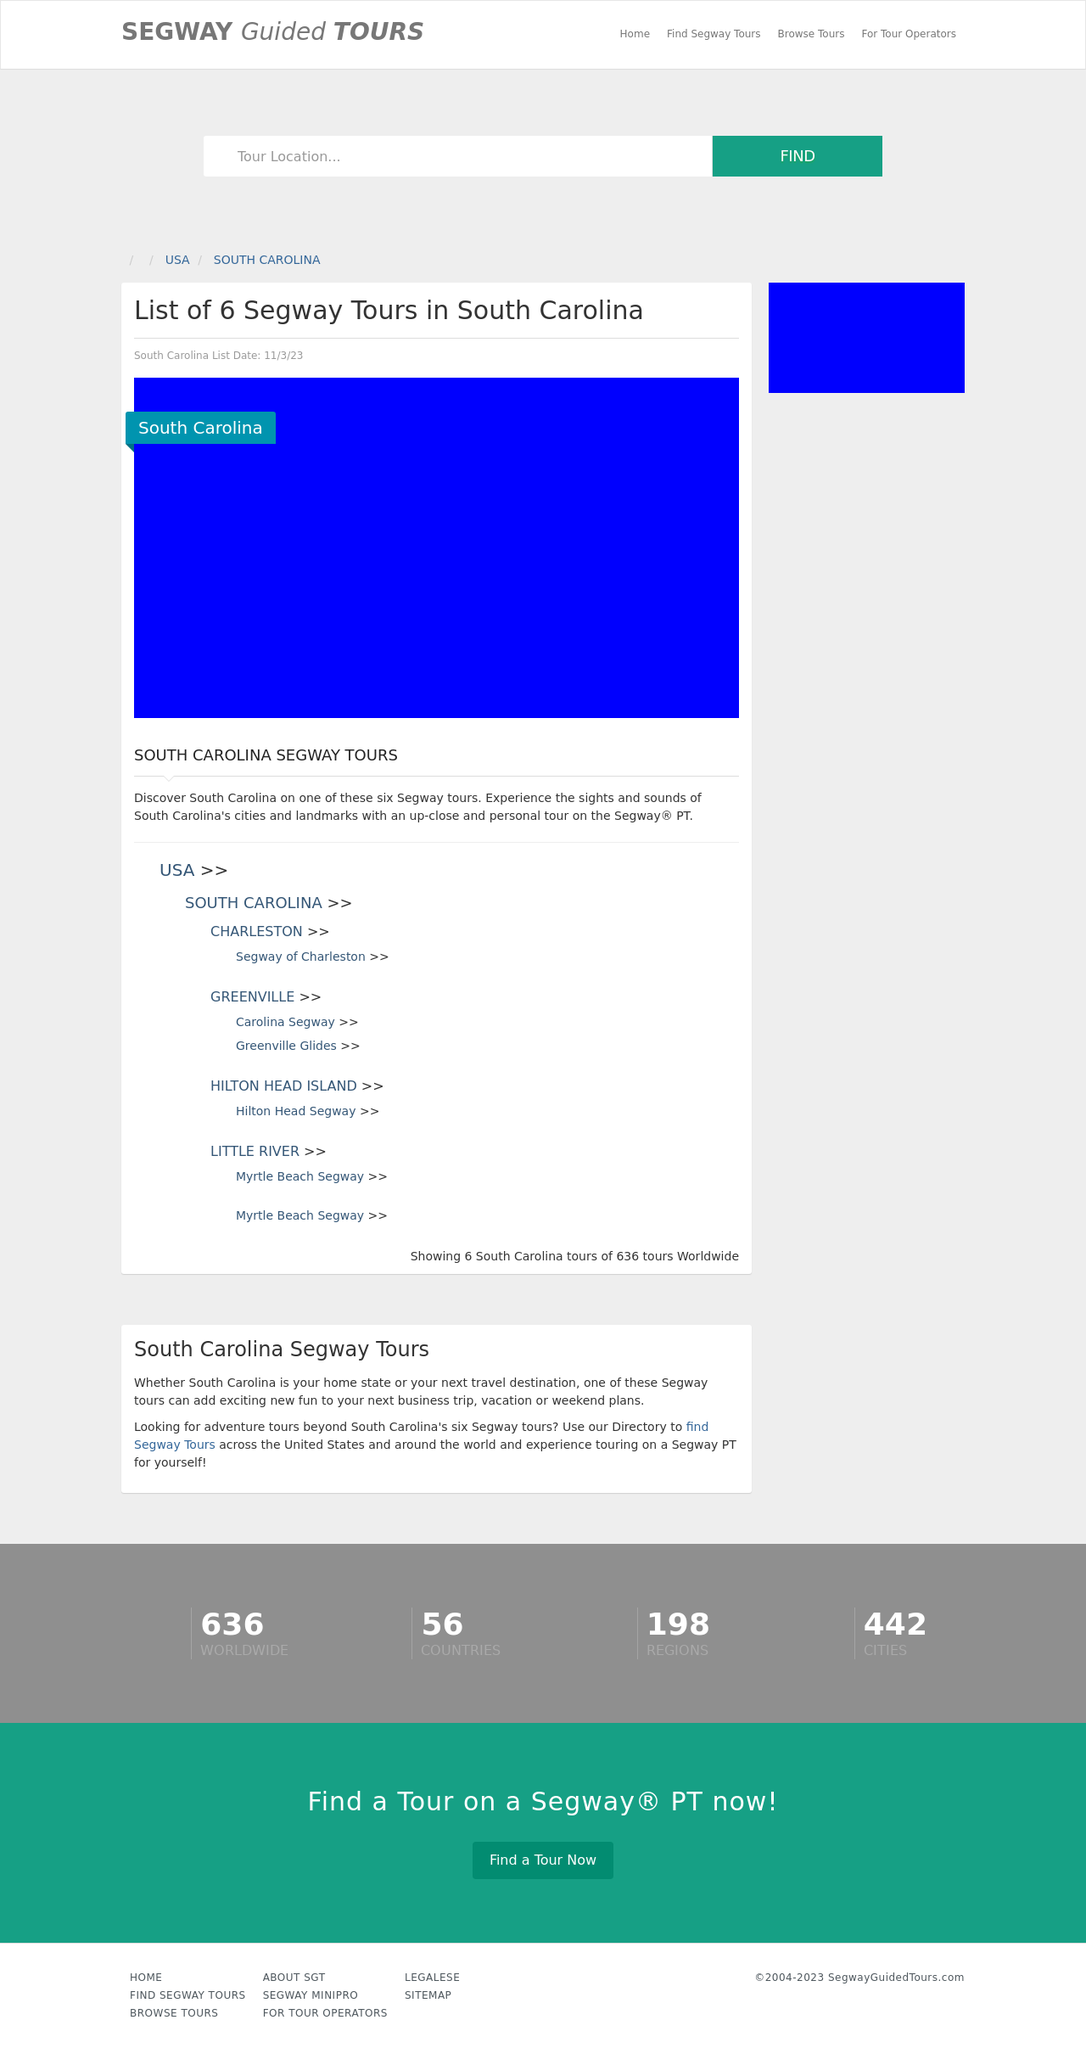What sort of information might the website provide about each tour in South Carolina? For each tour listed, the website might provide detailed information such as the name of the tour company, the specific route of the tour, key points of interest, duration and price. Additional helpful information may include availability dates, any necessary gear or preparations, and reviews or ratings from past participants to help visitors make informed decisions. 